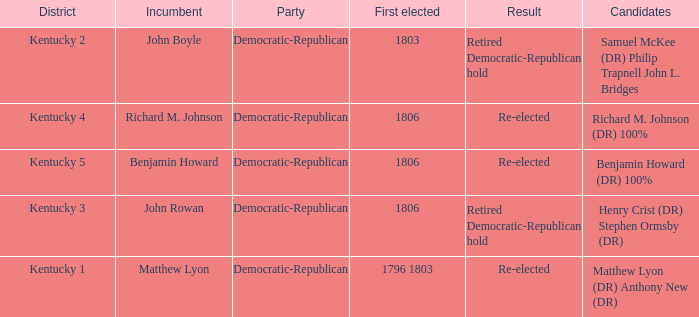Name the number of party for kentucky 1 1.0. 